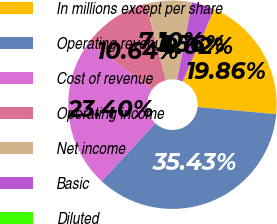Convert chart. <chart><loc_0><loc_0><loc_500><loc_500><pie_chart><fcel>In millions except per share<fcel>Operating revenue<fcel>Cost of revenue<fcel>Operating income<fcel>Net income<fcel>Basic<fcel>Diluted<nl><fcel>19.86%<fcel>35.43%<fcel>23.4%<fcel>10.64%<fcel>7.1%<fcel>3.56%<fcel>0.02%<nl></chart> 